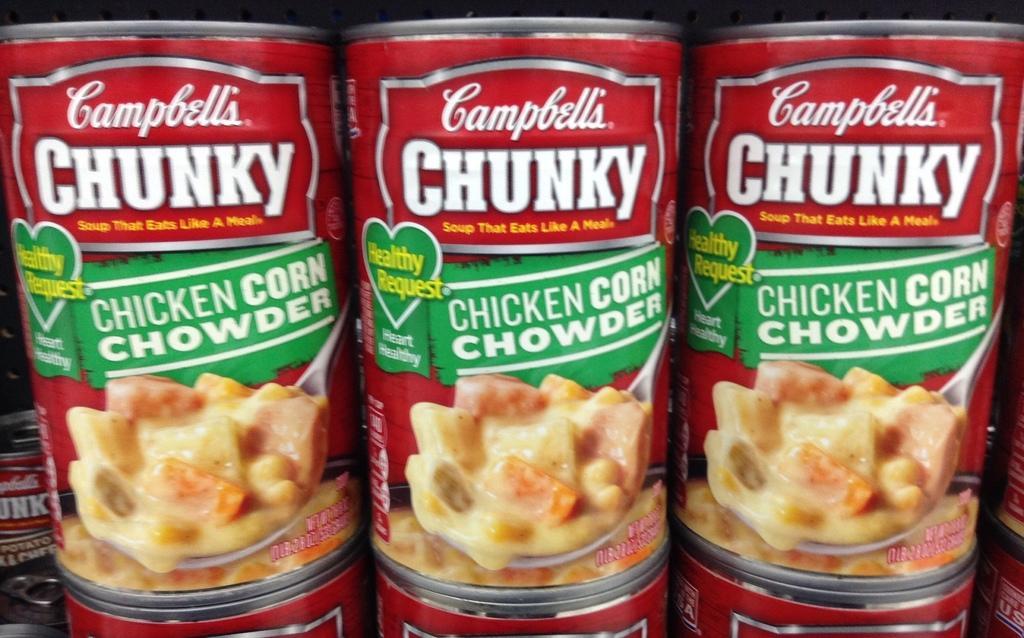Can you describe this image briefly? In the image in the center, we can see few cans. On the cans, it is written as "Chicken Corn Chowder". 